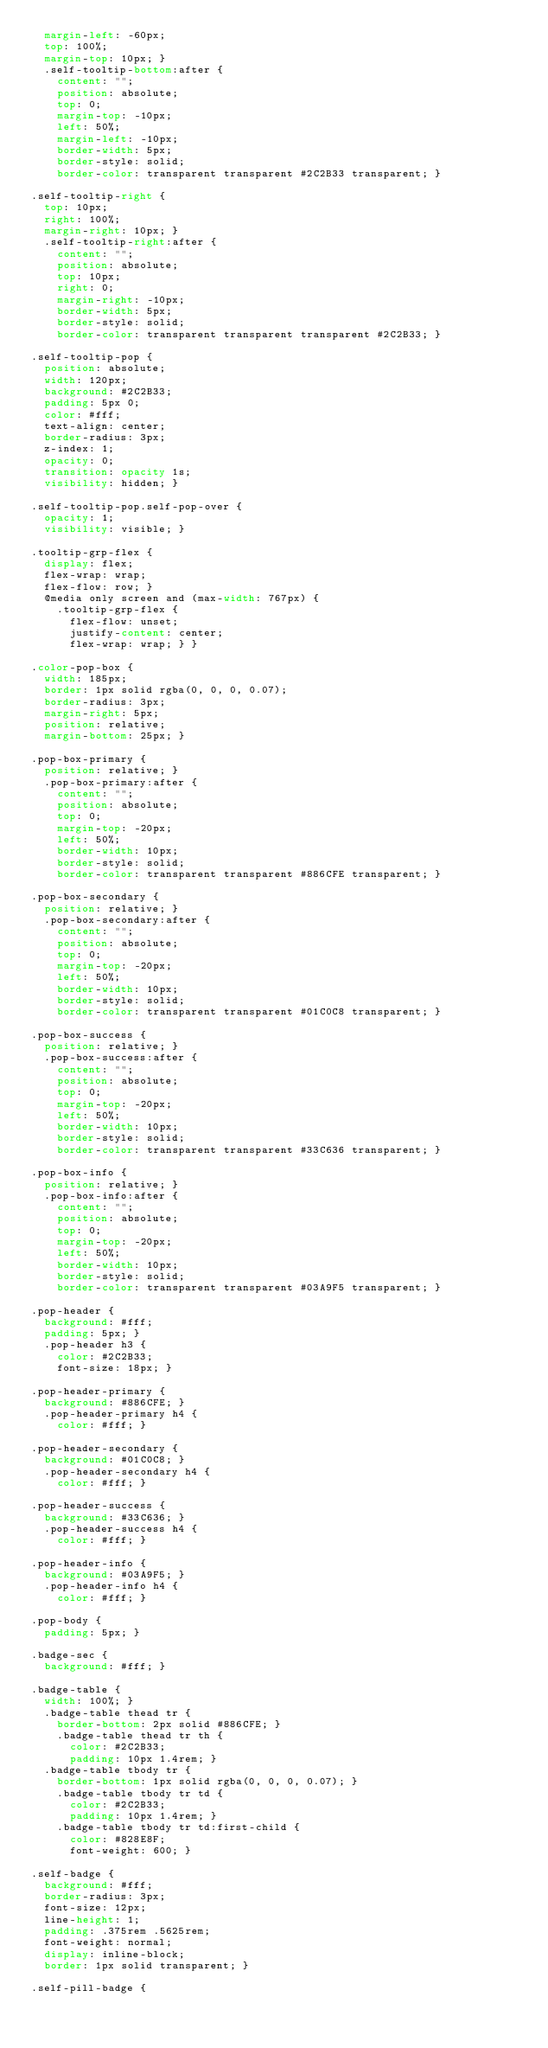Convert code to text. <code><loc_0><loc_0><loc_500><loc_500><_CSS_>  margin-left: -60px;
  top: 100%;
  margin-top: 10px; }
  .self-tooltip-bottom:after {
    content: "";
    position: absolute;
    top: 0;
    margin-top: -10px;
    left: 50%;
    margin-left: -10px;
    border-width: 5px;
    border-style: solid;
    border-color: transparent transparent #2C2B33 transparent; }

.self-tooltip-right {
  top: 10px;
  right: 100%;
  margin-right: 10px; }
  .self-tooltip-right:after {
    content: "";
    position: absolute;
    top: 10px;
    right: 0;
    margin-right: -10px;
    border-width: 5px;
    border-style: solid;
    border-color: transparent transparent transparent #2C2B33; }

.self-tooltip-pop {
  position: absolute;
  width: 120px;
  background: #2C2B33;
  padding: 5px 0;
  color: #fff;
  text-align: center;
  border-radius: 3px;
  z-index: 1;
  opacity: 0;
  transition: opacity 1s;
  visibility: hidden; }

.self-tooltip-pop.self-pop-over {
  opacity: 1;
  visibility: visible; }

.tooltip-grp-flex {
  display: flex;
  flex-wrap: wrap;
  flex-flow: row; }
  @media only screen and (max-width: 767px) {
    .tooltip-grp-flex {
      flex-flow: unset;
      justify-content: center;
      flex-wrap: wrap; } }

.color-pop-box {
  width: 185px;
  border: 1px solid rgba(0, 0, 0, 0.07);
  border-radius: 3px;
  margin-right: 5px;
  position: relative;
  margin-bottom: 25px; }

.pop-box-primary {
  position: relative; }
  .pop-box-primary:after {
    content: "";
    position: absolute;
    top: 0;
    margin-top: -20px;
    left: 50%;
    border-width: 10px;
    border-style: solid;
    border-color: transparent transparent #886CFE transparent; }

.pop-box-secondary {
  position: relative; }
  .pop-box-secondary:after {
    content: "";
    position: absolute;
    top: 0;
    margin-top: -20px;
    left: 50%;
    border-width: 10px;
    border-style: solid;
    border-color: transparent transparent #01C0C8 transparent; }

.pop-box-success {
  position: relative; }
  .pop-box-success:after {
    content: "";
    position: absolute;
    top: 0;
    margin-top: -20px;
    left: 50%;
    border-width: 10px;
    border-style: solid;
    border-color: transparent transparent #33C636 transparent; }

.pop-box-info {
  position: relative; }
  .pop-box-info:after {
    content: "";
    position: absolute;
    top: 0;
    margin-top: -20px;
    left: 50%;
    border-width: 10px;
    border-style: solid;
    border-color: transparent transparent #03A9F5 transparent; }

.pop-header {
  background: #fff;
  padding: 5px; }
  .pop-header h3 {
    color: #2C2B33;
    font-size: 18px; }

.pop-header-primary {
  background: #886CFE; }
  .pop-header-primary h4 {
    color: #fff; }

.pop-header-secondary {
  background: #01C0C8; }
  .pop-header-secondary h4 {
    color: #fff; }

.pop-header-success {
  background: #33C636; }
  .pop-header-success h4 {
    color: #fff; }

.pop-header-info {
  background: #03A9F5; }
  .pop-header-info h4 {
    color: #fff; }

.pop-body {
  padding: 5px; }

.badge-sec {
  background: #fff; }

.badge-table {
  width: 100%; }
  .badge-table thead tr {
    border-bottom: 2px solid #886CFE; }
    .badge-table thead tr th {
      color: #2C2B33;
      padding: 10px 1.4rem; }
  .badge-table tbody tr {
    border-bottom: 1px solid rgba(0, 0, 0, 0.07); }
    .badge-table tbody tr td {
      color: #2C2B33;
      padding: 10px 1.4rem; }
    .badge-table tbody tr td:first-child {
      color: #828E8F;
      font-weight: 600; }

.self-badge {
  background: #fff;
  border-radius: 3px;
  font-size: 12px;
  line-height: 1;
  padding: .375rem .5625rem;
  font-weight: normal;
  display: inline-block;
  border: 1px solid transparent; }

.self-pill-badge {</code> 